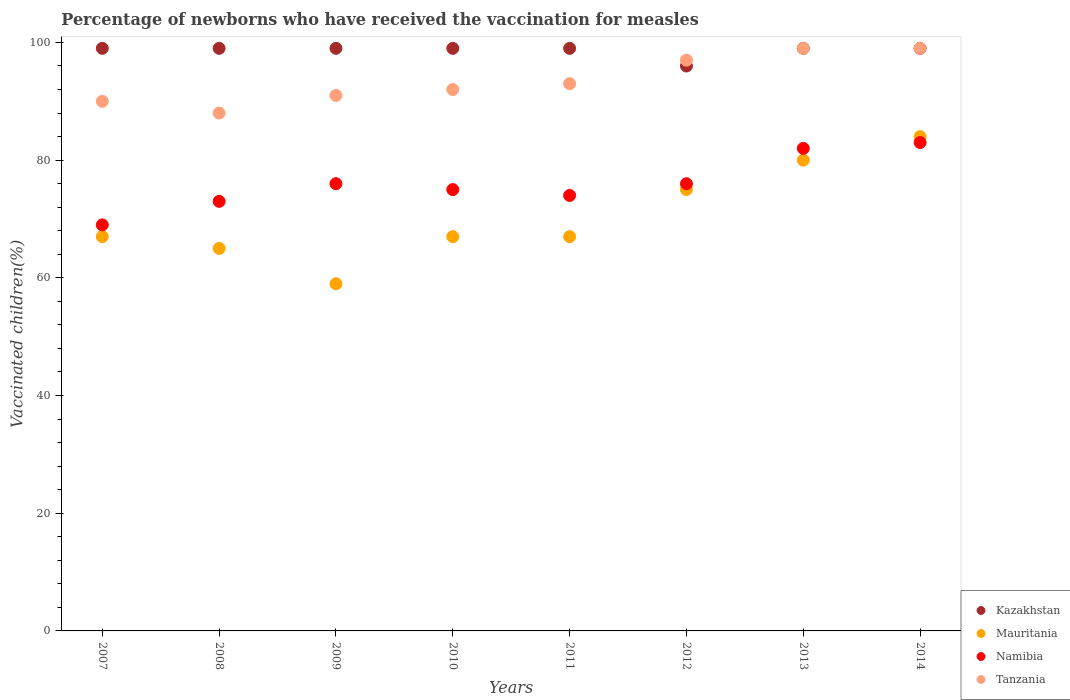Is the number of dotlines equal to the number of legend labels?
Offer a terse response. Yes. What is the percentage of vaccinated children in Tanzania in 2013?
Your response must be concise. 99. In which year was the percentage of vaccinated children in Namibia maximum?
Ensure brevity in your answer.  2014. What is the total percentage of vaccinated children in Tanzania in the graph?
Offer a very short reply. 749. What is the difference between the percentage of vaccinated children in Tanzania in 2010 and that in 2013?
Keep it short and to the point. -7. What is the difference between the percentage of vaccinated children in Mauritania in 2014 and the percentage of vaccinated children in Kazakhstan in 2009?
Your response must be concise. -15. What is the average percentage of vaccinated children in Namibia per year?
Your response must be concise. 76. In the year 2014, what is the difference between the percentage of vaccinated children in Mauritania and percentage of vaccinated children in Namibia?
Provide a short and direct response. 1. What is the ratio of the percentage of vaccinated children in Mauritania in 2012 to that in 2014?
Your response must be concise. 0.89. Is the percentage of vaccinated children in Kazakhstan in 2009 less than that in 2012?
Your answer should be compact. No. What is the difference between the highest and the second highest percentage of vaccinated children in Mauritania?
Keep it short and to the point. 4. What is the difference between the highest and the lowest percentage of vaccinated children in Namibia?
Your answer should be compact. 14. In how many years, is the percentage of vaccinated children in Tanzania greater than the average percentage of vaccinated children in Tanzania taken over all years?
Keep it short and to the point. 3. Is the sum of the percentage of vaccinated children in Kazakhstan in 2007 and 2014 greater than the maximum percentage of vaccinated children in Tanzania across all years?
Provide a succinct answer. Yes. Is it the case that in every year, the sum of the percentage of vaccinated children in Kazakhstan and percentage of vaccinated children in Namibia  is greater than the percentage of vaccinated children in Mauritania?
Offer a very short reply. Yes. What is the difference between two consecutive major ticks on the Y-axis?
Ensure brevity in your answer.  20. Does the graph contain any zero values?
Make the answer very short. No. Does the graph contain grids?
Offer a terse response. No. How are the legend labels stacked?
Give a very brief answer. Vertical. What is the title of the graph?
Your answer should be very brief. Percentage of newborns who have received the vaccination for measles. What is the label or title of the X-axis?
Your response must be concise. Years. What is the label or title of the Y-axis?
Provide a succinct answer. Vaccinated children(%). What is the Vaccinated children(%) in Mauritania in 2008?
Your answer should be very brief. 65. What is the Vaccinated children(%) in Namibia in 2008?
Provide a succinct answer. 73. What is the Vaccinated children(%) in Kazakhstan in 2009?
Provide a succinct answer. 99. What is the Vaccinated children(%) of Namibia in 2009?
Keep it short and to the point. 76. What is the Vaccinated children(%) of Tanzania in 2009?
Make the answer very short. 91. What is the Vaccinated children(%) of Kazakhstan in 2010?
Give a very brief answer. 99. What is the Vaccinated children(%) in Mauritania in 2010?
Your response must be concise. 67. What is the Vaccinated children(%) in Tanzania in 2010?
Make the answer very short. 92. What is the Vaccinated children(%) in Mauritania in 2011?
Your answer should be compact. 67. What is the Vaccinated children(%) in Namibia in 2011?
Provide a succinct answer. 74. What is the Vaccinated children(%) in Tanzania in 2011?
Ensure brevity in your answer.  93. What is the Vaccinated children(%) in Kazakhstan in 2012?
Offer a very short reply. 96. What is the Vaccinated children(%) of Tanzania in 2012?
Offer a very short reply. 97. What is the Vaccinated children(%) of Kazakhstan in 2013?
Offer a very short reply. 99. What is the Vaccinated children(%) of Mauritania in 2014?
Give a very brief answer. 84. What is the Vaccinated children(%) in Namibia in 2014?
Your response must be concise. 83. Across all years, what is the maximum Vaccinated children(%) of Kazakhstan?
Your answer should be compact. 99. Across all years, what is the maximum Vaccinated children(%) of Mauritania?
Your answer should be very brief. 84. Across all years, what is the maximum Vaccinated children(%) in Tanzania?
Provide a short and direct response. 99. Across all years, what is the minimum Vaccinated children(%) in Kazakhstan?
Your response must be concise. 96. Across all years, what is the minimum Vaccinated children(%) in Mauritania?
Your response must be concise. 59. What is the total Vaccinated children(%) of Kazakhstan in the graph?
Give a very brief answer. 789. What is the total Vaccinated children(%) in Mauritania in the graph?
Offer a very short reply. 564. What is the total Vaccinated children(%) in Namibia in the graph?
Make the answer very short. 608. What is the total Vaccinated children(%) in Tanzania in the graph?
Offer a terse response. 749. What is the difference between the Vaccinated children(%) in Tanzania in 2007 and that in 2008?
Your answer should be compact. 2. What is the difference between the Vaccinated children(%) in Kazakhstan in 2007 and that in 2009?
Your answer should be very brief. 0. What is the difference between the Vaccinated children(%) of Mauritania in 2007 and that in 2009?
Give a very brief answer. 8. What is the difference between the Vaccinated children(%) of Namibia in 2007 and that in 2009?
Your answer should be very brief. -7. What is the difference between the Vaccinated children(%) in Kazakhstan in 2007 and that in 2010?
Your answer should be compact. 0. What is the difference between the Vaccinated children(%) of Tanzania in 2007 and that in 2010?
Make the answer very short. -2. What is the difference between the Vaccinated children(%) in Kazakhstan in 2007 and that in 2011?
Provide a short and direct response. 0. What is the difference between the Vaccinated children(%) in Mauritania in 2007 and that in 2011?
Your response must be concise. 0. What is the difference between the Vaccinated children(%) in Tanzania in 2007 and that in 2011?
Your answer should be compact. -3. What is the difference between the Vaccinated children(%) in Kazakhstan in 2007 and that in 2012?
Provide a succinct answer. 3. What is the difference between the Vaccinated children(%) of Tanzania in 2007 and that in 2012?
Make the answer very short. -7. What is the difference between the Vaccinated children(%) in Namibia in 2007 and that in 2013?
Give a very brief answer. -13. What is the difference between the Vaccinated children(%) in Tanzania in 2007 and that in 2013?
Offer a terse response. -9. What is the difference between the Vaccinated children(%) of Mauritania in 2007 and that in 2014?
Provide a short and direct response. -17. What is the difference between the Vaccinated children(%) in Namibia in 2007 and that in 2014?
Offer a terse response. -14. What is the difference between the Vaccinated children(%) in Mauritania in 2008 and that in 2009?
Keep it short and to the point. 6. What is the difference between the Vaccinated children(%) of Namibia in 2008 and that in 2009?
Ensure brevity in your answer.  -3. What is the difference between the Vaccinated children(%) of Mauritania in 2008 and that in 2010?
Keep it short and to the point. -2. What is the difference between the Vaccinated children(%) of Kazakhstan in 2008 and that in 2011?
Keep it short and to the point. 0. What is the difference between the Vaccinated children(%) of Mauritania in 2008 and that in 2011?
Your answer should be very brief. -2. What is the difference between the Vaccinated children(%) of Namibia in 2008 and that in 2011?
Give a very brief answer. -1. What is the difference between the Vaccinated children(%) in Kazakhstan in 2008 and that in 2012?
Give a very brief answer. 3. What is the difference between the Vaccinated children(%) of Tanzania in 2008 and that in 2012?
Ensure brevity in your answer.  -9. What is the difference between the Vaccinated children(%) in Kazakhstan in 2008 and that in 2013?
Make the answer very short. 0. What is the difference between the Vaccinated children(%) in Namibia in 2008 and that in 2013?
Keep it short and to the point. -9. What is the difference between the Vaccinated children(%) of Namibia in 2008 and that in 2014?
Ensure brevity in your answer.  -10. What is the difference between the Vaccinated children(%) in Kazakhstan in 2009 and that in 2010?
Give a very brief answer. 0. What is the difference between the Vaccinated children(%) in Mauritania in 2009 and that in 2010?
Your answer should be very brief. -8. What is the difference between the Vaccinated children(%) of Tanzania in 2009 and that in 2010?
Give a very brief answer. -1. What is the difference between the Vaccinated children(%) in Mauritania in 2009 and that in 2011?
Keep it short and to the point. -8. What is the difference between the Vaccinated children(%) in Kazakhstan in 2009 and that in 2012?
Provide a succinct answer. 3. What is the difference between the Vaccinated children(%) in Mauritania in 2009 and that in 2013?
Offer a terse response. -21. What is the difference between the Vaccinated children(%) in Mauritania in 2009 and that in 2014?
Your response must be concise. -25. What is the difference between the Vaccinated children(%) in Namibia in 2009 and that in 2014?
Offer a terse response. -7. What is the difference between the Vaccinated children(%) in Mauritania in 2010 and that in 2011?
Your response must be concise. 0. What is the difference between the Vaccinated children(%) of Namibia in 2010 and that in 2011?
Offer a very short reply. 1. What is the difference between the Vaccinated children(%) in Tanzania in 2010 and that in 2011?
Make the answer very short. -1. What is the difference between the Vaccinated children(%) in Namibia in 2010 and that in 2012?
Provide a short and direct response. -1. What is the difference between the Vaccinated children(%) in Namibia in 2010 and that in 2013?
Ensure brevity in your answer.  -7. What is the difference between the Vaccinated children(%) of Kazakhstan in 2010 and that in 2014?
Your answer should be compact. 0. What is the difference between the Vaccinated children(%) in Namibia in 2010 and that in 2014?
Ensure brevity in your answer.  -8. What is the difference between the Vaccinated children(%) in Tanzania in 2010 and that in 2014?
Ensure brevity in your answer.  -7. What is the difference between the Vaccinated children(%) of Kazakhstan in 2011 and that in 2012?
Your answer should be very brief. 3. What is the difference between the Vaccinated children(%) of Namibia in 2011 and that in 2012?
Ensure brevity in your answer.  -2. What is the difference between the Vaccinated children(%) of Tanzania in 2011 and that in 2012?
Your answer should be compact. -4. What is the difference between the Vaccinated children(%) in Kazakhstan in 2011 and that in 2013?
Your answer should be very brief. 0. What is the difference between the Vaccinated children(%) of Namibia in 2011 and that in 2014?
Offer a very short reply. -9. What is the difference between the Vaccinated children(%) in Tanzania in 2011 and that in 2014?
Your answer should be compact. -6. What is the difference between the Vaccinated children(%) in Namibia in 2012 and that in 2013?
Offer a very short reply. -6. What is the difference between the Vaccinated children(%) in Tanzania in 2012 and that in 2013?
Provide a succinct answer. -2. What is the difference between the Vaccinated children(%) of Tanzania in 2012 and that in 2014?
Offer a terse response. -2. What is the difference between the Vaccinated children(%) of Kazakhstan in 2013 and that in 2014?
Your response must be concise. 0. What is the difference between the Vaccinated children(%) of Mauritania in 2013 and that in 2014?
Keep it short and to the point. -4. What is the difference between the Vaccinated children(%) in Namibia in 2013 and that in 2014?
Provide a short and direct response. -1. What is the difference between the Vaccinated children(%) of Tanzania in 2013 and that in 2014?
Your answer should be very brief. 0. What is the difference between the Vaccinated children(%) in Kazakhstan in 2007 and the Vaccinated children(%) in Mauritania in 2008?
Your answer should be compact. 34. What is the difference between the Vaccinated children(%) of Kazakhstan in 2007 and the Vaccinated children(%) of Tanzania in 2008?
Provide a short and direct response. 11. What is the difference between the Vaccinated children(%) of Kazakhstan in 2007 and the Vaccinated children(%) of Mauritania in 2009?
Keep it short and to the point. 40. What is the difference between the Vaccinated children(%) in Namibia in 2007 and the Vaccinated children(%) in Tanzania in 2009?
Provide a succinct answer. -22. What is the difference between the Vaccinated children(%) of Kazakhstan in 2007 and the Vaccinated children(%) of Mauritania in 2010?
Give a very brief answer. 32. What is the difference between the Vaccinated children(%) of Kazakhstan in 2007 and the Vaccinated children(%) of Tanzania in 2010?
Ensure brevity in your answer.  7. What is the difference between the Vaccinated children(%) of Mauritania in 2007 and the Vaccinated children(%) of Tanzania in 2010?
Keep it short and to the point. -25. What is the difference between the Vaccinated children(%) in Kazakhstan in 2007 and the Vaccinated children(%) in Mauritania in 2011?
Your answer should be very brief. 32. What is the difference between the Vaccinated children(%) of Kazakhstan in 2007 and the Vaccinated children(%) of Namibia in 2011?
Your answer should be very brief. 25. What is the difference between the Vaccinated children(%) of Kazakhstan in 2007 and the Vaccinated children(%) of Tanzania in 2011?
Your answer should be very brief. 6. What is the difference between the Vaccinated children(%) in Mauritania in 2007 and the Vaccinated children(%) in Namibia in 2011?
Offer a terse response. -7. What is the difference between the Vaccinated children(%) in Namibia in 2007 and the Vaccinated children(%) in Tanzania in 2011?
Provide a short and direct response. -24. What is the difference between the Vaccinated children(%) of Namibia in 2007 and the Vaccinated children(%) of Tanzania in 2012?
Make the answer very short. -28. What is the difference between the Vaccinated children(%) of Mauritania in 2007 and the Vaccinated children(%) of Namibia in 2013?
Your response must be concise. -15. What is the difference between the Vaccinated children(%) in Mauritania in 2007 and the Vaccinated children(%) in Tanzania in 2013?
Make the answer very short. -32. What is the difference between the Vaccinated children(%) of Kazakhstan in 2007 and the Vaccinated children(%) of Mauritania in 2014?
Provide a succinct answer. 15. What is the difference between the Vaccinated children(%) of Mauritania in 2007 and the Vaccinated children(%) of Namibia in 2014?
Provide a short and direct response. -16. What is the difference between the Vaccinated children(%) of Mauritania in 2007 and the Vaccinated children(%) of Tanzania in 2014?
Ensure brevity in your answer.  -32. What is the difference between the Vaccinated children(%) in Kazakhstan in 2008 and the Vaccinated children(%) in Namibia in 2009?
Provide a short and direct response. 23. What is the difference between the Vaccinated children(%) in Kazakhstan in 2008 and the Vaccinated children(%) in Tanzania in 2009?
Give a very brief answer. 8. What is the difference between the Vaccinated children(%) of Mauritania in 2008 and the Vaccinated children(%) of Namibia in 2009?
Offer a very short reply. -11. What is the difference between the Vaccinated children(%) of Mauritania in 2008 and the Vaccinated children(%) of Tanzania in 2009?
Offer a very short reply. -26. What is the difference between the Vaccinated children(%) in Kazakhstan in 2008 and the Vaccinated children(%) in Namibia in 2010?
Offer a terse response. 24. What is the difference between the Vaccinated children(%) of Kazakhstan in 2008 and the Vaccinated children(%) of Tanzania in 2010?
Keep it short and to the point. 7. What is the difference between the Vaccinated children(%) in Kazakhstan in 2008 and the Vaccinated children(%) in Mauritania in 2011?
Give a very brief answer. 32. What is the difference between the Vaccinated children(%) in Kazakhstan in 2008 and the Vaccinated children(%) in Namibia in 2011?
Offer a very short reply. 25. What is the difference between the Vaccinated children(%) of Kazakhstan in 2008 and the Vaccinated children(%) of Tanzania in 2011?
Your response must be concise. 6. What is the difference between the Vaccinated children(%) in Mauritania in 2008 and the Vaccinated children(%) in Namibia in 2011?
Make the answer very short. -9. What is the difference between the Vaccinated children(%) of Mauritania in 2008 and the Vaccinated children(%) of Namibia in 2012?
Provide a succinct answer. -11. What is the difference between the Vaccinated children(%) of Mauritania in 2008 and the Vaccinated children(%) of Tanzania in 2012?
Your response must be concise. -32. What is the difference between the Vaccinated children(%) of Namibia in 2008 and the Vaccinated children(%) of Tanzania in 2012?
Your answer should be very brief. -24. What is the difference between the Vaccinated children(%) of Kazakhstan in 2008 and the Vaccinated children(%) of Mauritania in 2013?
Ensure brevity in your answer.  19. What is the difference between the Vaccinated children(%) of Mauritania in 2008 and the Vaccinated children(%) of Tanzania in 2013?
Provide a short and direct response. -34. What is the difference between the Vaccinated children(%) of Namibia in 2008 and the Vaccinated children(%) of Tanzania in 2013?
Offer a very short reply. -26. What is the difference between the Vaccinated children(%) of Mauritania in 2008 and the Vaccinated children(%) of Tanzania in 2014?
Ensure brevity in your answer.  -34. What is the difference between the Vaccinated children(%) of Kazakhstan in 2009 and the Vaccinated children(%) of Mauritania in 2010?
Offer a very short reply. 32. What is the difference between the Vaccinated children(%) in Kazakhstan in 2009 and the Vaccinated children(%) in Namibia in 2010?
Keep it short and to the point. 24. What is the difference between the Vaccinated children(%) in Mauritania in 2009 and the Vaccinated children(%) in Tanzania in 2010?
Make the answer very short. -33. What is the difference between the Vaccinated children(%) of Namibia in 2009 and the Vaccinated children(%) of Tanzania in 2010?
Keep it short and to the point. -16. What is the difference between the Vaccinated children(%) of Kazakhstan in 2009 and the Vaccinated children(%) of Mauritania in 2011?
Provide a short and direct response. 32. What is the difference between the Vaccinated children(%) of Kazakhstan in 2009 and the Vaccinated children(%) of Namibia in 2011?
Give a very brief answer. 25. What is the difference between the Vaccinated children(%) in Mauritania in 2009 and the Vaccinated children(%) in Namibia in 2011?
Your answer should be very brief. -15. What is the difference between the Vaccinated children(%) of Mauritania in 2009 and the Vaccinated children(%) of Tanzania in 2011?
Your response must be concise. -34. What is the difference between the Vaccinated children(%) in Kazakhstan in 2009 and the Vaccinated children(%) in Mauritania in 2012?
Make the answer very short. 24. What is the difference between the Vaccinated children(%) of Kazakhstan in 2009 and the Vaccinated children(%) of Namibia in 2012?
Your answer should be very brief. 23. What is the difference between the Vaccinated children(%) in Kazakhstan in 2009 and the Vaccinated children(%) in Tanzania in 2012?
Your response must be concise. 2. What is the difference between the Vaccinated children(%) of Mauritania in 2009 and the Vaccinated children(%) of Tanzania in 2012?
Ensure brevity in your answer.  -38. What is the difference between the Vaccinated children(%) of Namibia in 2009 and the Vaccinated children(%) of Tanzania in 2012?
Give a very brief answer. -21. What is the difference between the Vaccinated children(%) of Kazakhstan in 2009 and the Vaccinated children(%) of Tanzania in 2013?
Give a very brief answer. 0. What is the difference between the Vaccinated children(%) of Mauritania in 2009 and the Vaccinated children(%) of Namibia in 2013?
Make the answer very short. -23. What is the difference between the Vaccinated children(%) in Mauritania in 2009 and the Vaccinated children(%) in Tanzania in 2013?
Provide a succinct answer. -40. What is the difference between the Vaccinated children(%) of Namibia in 2009 and the Vaccinated children(%) of Tanzania in 2013?
Offer a terse response. -23. What is the difference between the Vaccinated children(%) of Kazakhstan in 2009 and the Vaccinated children(%) of Namibia in 2014?
Your response must be concise. 16. What is the difference between the Vaccinated children(%) of Namibia in 2009 and the Vaccinated children(%) of Tanzania in 2014?
Offer a very short reply. -23. What is the difference between the Vaccinated children(%) of Kazakhstan in 2010 and the Vaccinated children(%) of Tanzania in 2011?
Your answer should be very brief. 6. What is the difference between the Vaccinated children(%) in Mauritania in 2010 and the Vaccinated children(%) in Tanzania in 2011?
Ensure brevity in your answer.  -26. What is the difference between the Vaccinated children(%) of Kazakhstan in 2010 and the Vaccinated children(%) of Namibia in 2012?
Give a very brief answer. 23. What is the difference between the Vaccinated children(%) of Mauritania in 2010 and the Vaccinated children(%) of Tanzania in 2012?
Your response must be concise. -30. What is the difference between the Vaccinated children(%) in Namibia in 2010 and the Vaccinated children(%) in Tanzania in 2012?
Ensure brevity in your answer.  -22. What is the difference between the Vaccinated children(%) of Kazakhstan in 2010 and the Vaccinated children(%) of Tanzania in 2013?
Give a very brief answer. 0. What is the difference between the Vaccinated children(%) of Mauritania in 2010 and the Vaccinated children(%) of Namibia in 2013?
Provide a succinct answer. -15. What is the difference between the Vaccinated children(%) in Mauritania in 2010 and the Vaccinated children(%) in Tanzania in 2013?
Offer a terse response. -32. What is the difference between the Vaccinated children(%) in Namibia in 2010 and the Vaccinated children(%) in Tanzania in 2013?
Offer a terse response. -24. What is the difference between the Vaccinated children(%) of Kazakhstan in 2010 and the Vaccinated children(%) of Mauritania in 2014?
Ensure brevity in your answer.  15. What is the difference between the Vaccinated children(%) of Kazakhstan in 2010 and the Vaccinated children(%) of Namibia in 2014?
Ensure brevity in your answer.  16. What is the difference between the Vaccinated children(%) of Mauritania in 2010 and the Vaccinated children(%) of Namibia in 2014?
Provide a succinct answer. -16. What is the difference between the Vaccinated children(%) in Mauritania in 2010 and the Vaccinated children(%) in Tanzania in 2014?
Provide a succinct answer. -32. What is the difference between the Vaccinated children(%) in Kazakhstan in 2011 and the Vaccinated children(%) in Mauritania in 2012?
Your response must be concise. 24. What is the difference between the Vaccinated children(%) in Kazakhstan in 2011 and the Vaccinated children(%) in Namibia in 2012?
Your answer should be very brief. 23. What is the difference between the Vaccinated children(%) in Mauritania in 2011 and the Vaccinated children(%) in Namibia in 2012?
Offer a very short reply. -9. What is the difference between the Vaccinated children(%) in Kazakhstan in 2011 and the Vaccinated children(%) in Tanzania in 2013?
Provide a succinct answer. 0. What is the difference between the Vaccinated children(%) in Mauritania in 2011 and the Vaccinated children(%) in Tanzania in 2013?
Ensure brevity in your answer.  -32. What is the difference between the Vaccinated children(%) in Namibia in 2011 and the Vaccinated children(%) in Tanzania in 2013?
Your answer should be compact. -25. What is the difference between the Vaccinated children(%) in Kazakhstan in 2011 and the Vaccinated children(%) in Mauritania in 2014?
Provide a short and direct response. 15. What is the difference between the Vaccinated children(%) of Mauritania in 2011 and the Vaccinated children(%) of Namibia in 2014?
Your response must be concise. -16. What is the difference between the Vaccinated children(%) of Mauritania in 2011 and the Vaccinated children(%) of Tanzania in 2014?
Give a very brief answer. -32. What is the difference between the Vaccinated children(%) of Kazakhstan in 2012 and the Vaccinated children(%) of Namibia in 2013?
Your response must be concise. 14. What is the difference between the Vaccinated children(%) in Namibia in 2012 and the Vaccinated children(%) in Tanzania in 2013?
Offer a terse response. -23. What is the difference between the Vaccinated children(%) in Kazakhstan in 2012 and the Vaccinated children(%) in Tanzania in 2014?
Offer a very short reply. -3. What is the difference between the Vaccinated children(%) of Kazakhstan in 2013 and the Vaccinated children(%) of Mauritania in 2014?
Keep it short and to the point. 15. What is the difference between the Vaccinated children(%) in Namibia in 2013 and the Vaccinated children(%) in Tanzania in 2014?
Keep it short and to the point. -17. What is the average Vaccinated children(%) in Kazakhstan per year?
Keep it short and to the point. 98.62. What is the average Vaccinated children(%) in Mauritania per year?
Offer a terse response. 70.5. What is the average Vaccinated children(%) in Tanzania per year?
Make the answer very short. 93.62. In the year 2007, what is the difference between the Vaccinated children(%) in Kazakhstan and Vaccinated children(%) in Mauritania?
Ensure brevity in your answer.  32. In the year 2007, what is the difference between the Vaccinated children(%) of Mauritania and Vaccinated children(%) of Namibia?
Your answer should be very brief. -2. In the year 2007, what is the difference between the Vaccinated children(%) in Mauritania and Vaccinated children(%) in Tanzania?
Provide a succinct answer. -23. In the year 2007, what is the difference between the Vaccinated children(%) in Namibia and Vaccinated children(%) in Tanzania?
Offer a terse response. -21. In the year 2008, what is the difference between the Vaccinated children(%) in Namibia and Vaccinated children(%) in Tanzania?
Your response must be concise. -15. In the year 2009, what is the difference between the Vaccinated children(%) of Kazakhstan and Vaccinated children(%) of Mauritania?
Provide a succinct answer. 40. In the year 2009, what is the difference between the Vaccinated children(%) of Kazakhstan and Vaccinated children(%) of Namibia?
Make the answer very short. 23. In the year 2009, what is the difference between the Vaccinated children(%) in Mauritania and Vaccinated children(%) in Tanzania?
Ensure brevity in your answer.  -32. In the year 2009, what is the difference between the Vaccinated children(%) in Namibia and Vaccinated children(%) in Tanzania?
Offer a terse response. -15. In the year 2010, what is the difference between the Vaccinated children(%) of Kazakhstan and Vaccinated children(%) of Tanzania?
Ensure brevity in your answer.  7. In the year 2010, what is the difference between the Vaccinated children(%) in Mauritania and Vaccinated children(%) in Namibia?
Your answer should be compact. -8. In the year 2011, what is the difference between the Vaccinated children(%) in Kazakhstan and Vaccinated children(%) in Mauritania?
Offer a very short reply. 32. In the year 2011, what is the difference between the Vaccinated children(%) of Mauritania and Vaccinated children(%) of Namibia?
Give a very brief answer. -7. In the year 2011, what is the difference between the Vaccinated children(%) of Mauritania and Vaccinated children(%) of Tanzania?
Your answer should be very brief. -26. In the year 2012, what is the difference between the Vaccinated children(%) in Kazakhstan and Vaccinated children(%) in Tanzania?
Give a very brief answer. -1. In the year 2012, what is the difference between the Vaccinated children(%) of Mauritania and Vaccinated children(%) of Namibia?
Offer a terse response. -1. In the year 2012, what is the difference between the Vaccinated children(%) of Mauritania and Vaccinated children(%) of Tanzania?
Offer a terse response. -22. In the year 2012, what is the difference between the Vaccinated children(%) in Namibia and Vaccinated children(%) in Tanzania?
Offer a very short reply. -21. In the year 2013, what is the difference between the Vaccinated children(%) in Kazakhstan and Vaccinated children(%) in Mauritania?
Your answer should be compact. 19. In the year 2013, what is the difference between the Vaccinated children(%) in Kazakhstan and Vaccinated children(%) in Tanzania?
Your answer should be compact. 0. In the year 2013, what is the difference between the Vaccinated children(%) in Mauritania and Vaccinated children(%) in Tanzania?
Make the answer very short. -19. In the year 2013, what is the difference between the Vaccinated children(%) in Namibia and Vaccinated children(%) in Tanzania?
Make the answer very short. -17. In the year 2014, what is the difference between the Vaccinated children(%) in Kazakhstan and Vaccinated children(%) in Mauritania?
Offer a terse response. 15. In the year 2014, what is the difference between the Vaccinated children(%) of Mauritania and Vaccinated children(%) of Namibia?
Your answer should be very brief. 1. In the year 2014, what is the difference between the Vaccinated children(%) in Mauritania and Vaccinated children(%) in Tanzania?
Ensure brevity in your answer.  -15. In the year 2014, what is the difference between the Vaccinated children(%) of Namibia and Vaccinated children(%) of Tanzania?
Your response must be concise. -16. What is the ratio of the Vaccinated children(%) in Mauritania in 2007 to that in 2008?
Keep it short and to the point. 1.03. What is the ratio of the Vaccinated children(%) of Namibia in 2007 to that in 2008?
Offer a terse response. 0.95. What is the ratio of the Vaccinated children(%) of Tanzania in 2007 to that in 2008?
Your answer should be very brief. 1.02. What is the ratio of the Vaccinated children(%) of Kazakhstan in 2007 to that in 2009?
Provide a succinct answer. 1. What is the ratio of the Vaccinated children(%) in Mauritania in 2007 to that in 2009?
Give a very brief answer. 1.14. What is the ratio of the Vaccinated children(%) in Namibia in 2007 to that in 2009?
Keep it short and to the point. 0.91. What is the ratio of the Vaccinated children(%) of Tanzania in 2007 to that in 2009?
Provide a short and direct response. 0.99. What is the ratio of the Vaccinated children(%) in Mauritania in 2007 to that in 2010?
Provide a short and direct response. 1. What is the ratio of the Vaccinated children(%) of Namibia in 2007 to that in 2010?
Keep it short and to the point. 0.92. What is the ratio of the Vaccinated children(%) in Tanzania in 2007 to that in 2010?
Your response must be concise. 0.98. What is the ratio of the Vaccinated children(%) in Mauritania in 2007 to that in 2011?
Your answer should be compact. 1. What is the ratio of the Vaccinated children(%) of Namibia in 2007 to that in 2011?
Provide a short and direct response. 0.93. What is the ratio of the Vaccinated children(%) in Kazakhstan in 2007 to that in 2012?
Your answer should be very brief. 1.03. What is the ratio of the Vaccinated children(%) in Mauritania in 2007 to that in 2012?
Offer a very short reply. 0.89. What is the ratio of the Vaccinated children(%) in Namibia in 2007 to that in 2012?
Offer a very short reply. 0.91. What is the ratio of the Vaccinated children(%) in Tanzania in 2007 to that in 2012?
Ensure brevity in your answer.  0.93. What is the ratio of the Vaccinated children(%) in Kazakhstan in 2007 to that in 2013?
Your response must be concise. 1. What is the ratio of the Vaccinated children(%) of Mauritania in 2007 to that in 2013?
Offer a terse response. 0.84. What is the ratio of the Vaccinated children(%) in Namibia in 2007 to that in 2013?
Make the answer very short. 0.84. What is the ratio of the Vaccinated children(%) in Tanzania in 2007 to that in 2013?
Your answer should be very brief. 0.91. What is the ratio of the Vaccinated children(%) in Kazakhstan in 2007 to that in 2014?
Your answer should be very brief. 1. What is the ratio of the Vaccinated children(%) of Mauritania in 2007 to that in 2014?
Make the answer very short. 0.8. What is the ratio of the Vaccinated children(%) of Namibia in 2007 to that in 2014?
Give a very brief answer. 0.83. What is the ratio of the Vaccinated children(%) of Mauritania in 2008 to that in 2009?
Your response must be concise. 1.1. What is the ratio of the Vaccinated children(%) of Namibia in 2008 to that in 2009?
Your answer should be compact. 0.96. What is the ratio of the Vaccinated children(%) of Tanzania in 2008 to that in 2009?
Your response must be concise. 0.97. What is the ratio of the Vaccinated children(%) in Kazakhstan in 2008 to that in 2010?
Give a very brief answer. 1. What is the ratio of the Vaccinated children(%) in Mauritania in 2008 to that in 2010?
Provide a succinct answer. 0.97. What is the ratio of the Vaccinated children(%) in Namibia in 2008 to that in 2010?
Offer a terse response. 0.97. What is the ratio of the Vaccinated children(%) of Tanzania in 2008 to that in 2010?
Your answer should be very brief. 0.96. What is the ratio of the Vaccinated children(%) of Mauritania in 2008 to that in 2011?
Keep it short and to the point. 0.97. What is the ratio of the Vaccinated children(%) of Namibia in 2008 to that in 2011?
Your answer should be compact. 0.99. What is the ratio of the Vaccinated children(%) in Tanzania in 2008 to that in 2011?
Your answer should be compact. 0.95. What is the ratio of the Vaccinated children(%) of Kazakhstan in 2008 to that in 2012?
Offer a terse response. 1.03. What is the ratio of the Vaccinated children(%) in Mauritania in 2008 to that in 2012?
Your answer should be very brief. 0.87. What is the ratio of the Vaccinated children(%) of Namibia in 2008 to that in 2012?
Give a very brief answer. 0.96. What is the ratio of the Vaccinated children(%) of Tanzania in 2008 to that in 2012?
Your response must be concise. 0.91. What is the ratio of the Vaccinated children(%) in Mauritania in 2008 to that in 2013?
Provide a succinct answer. 0.81. What is the ratio of the Vaccinated children(%) of Namibia in 2008 to that in 2013?
Make the answer very short. 0.89. What is the ratio of the Vaccinated children(%) in Mauritania in 2008 to that in 2014?
Ensure brevity in your answer.  0.77. What is the ratio of the Vaccinated children(%) in Namibia in 2008 to that in 2014?
Your answer should be compact. 0.88. What is the ratio of the Vaccinated children(%) of Tanzania in 2008 to that in 2014?
Ensure brevity in your answer.  0.89. What is the ratio of the Vaccinated children(%) in Kazakhstan in 2009 to that in 2010?
Ensure brevity in your answer.  1. What is the ratio of the Vaccinated children(%) of Mauritania in 2009 to that in 2010?
Offer a very short reply. 0.88. What is the ratio of the Vaccinated children(%) of Namibia in 2009 to that in 2010?
Make the answer very short. 1.01. What is the ratio of the Vaccinated children(%) of Mauritania in 2009 to that in 2011?
Keep it short and to the point. 0.88. What is the ratio of the Vaccinated children(%) of Namibia in 2009 to that in 2011?
Your answer should be compact. 1.03. What is the ratio of the Vaccinated children(%) of Tanzania in 2009 to that in 2011?
Your answer should be very brief. 0.98. What is the ratio of the Vaccinated children(%) of Kazakhstan in 2009 to that in 2012?
Provide a short and direct response. 1.03. What is the ratio of the Vaccinated children(%) in Mauritania in 2009 to that in 2012?
Keep it short and to the point. 0.79. What is the ratio of the Vaccinated children(%) in Namibia in 2009 to that in 2012?
Provide a short and direct response. 1. What is the ratio of the Vaccinated children(%) in Tanzania in 2009 to that in 2012?
Give a very brief answer. 0.94. What is the ratio of the Vaccinated children(%) in Mauritania in 2009 to that in 2013?
Your answer should be compact. 0.74. What is the ratio of the Vaccinated children(%) of Namibia in 2009 to that in 2013?
Make the answer very short. 0.93. What is the ratio of the Vaccinated children(%) in Tanzania in 2009 to that in 2013?
Ensure brevity in your answer.  0.92. What is the ratio of the Vaccinated children(%) in Kazakhstan in 2009 to that in 2014?
Your response must be concise. 1. What is the ratio of the Vaccinated children(%) of Mauritania in 2009 to that in 2014?
Your response must be concise. 0.7. What is the ratio of the Vaccinated children(%) of Namibia in 2009 to that in 2014?
Provide a succinct answer. 0.92. What is the ratio of the Vaccinated children(%) in Tanzania in 2009 to that in 2014?
Keep it short and to the point. 0.92. What is the ratio of the Vaccinated children(%) of Kazakhstan in 2010 to that in 2011?
Give a very brief answer. 1. What is the ratio of the Vaccinated children(%) in Mauritania in 2010 to that in 2011?
Your answer should be very brief. 1. What is the ratio of the Vaccinated children(%) in Namibia in 2010 to that in 2011?
Your answer should be very brief. 1.01. What is the ratio of the Vaccinated children(%) in Tanzania in 2010 to that in 2011?
Your answer should be compact. 0.99. What is the ratio of the Vaccinated children(%) in Kazakhstan in 2010 to that in 2012?
Make the answer very short. 1.03. What is the ratio of the Vaccinated children(%) in Mauritania in 2010 to that in 2012?
Provide a succinct answer. 0.89. What is the ratio of the Vaccinated children(%) of Tanzania in 2010 to that in 2012?
Offer a very short reply. 0.95. What is the ratio of the Vaccinated children(%) of Kazakhstan in 2010 to that in 2013?
Give a very brief answer. 1. What is the ratio of the Vaccinated children(%) of Mauritania in 2010 to that in 2013?
Your answer should be compact. 0.84. What is the ratio of the Vaccinated children(%) of Namibia in 2010 to that in 2013?
Offer a terse response. 0.91. What is the ratio of the Vaccinated children(%) of Tanzania in 2010 to that in 2013?
Your answer should be compact. 0.93. What is the ratio of the Vaccinated children(%) of Mauritania in 2010 to that in 2014?
Your answer should be compact. 0.8. What is the ratio of the Vaccinated children(%) of Namibia in 2010 to that in 2014?
Provide a short and direct response. 0.9. What is the ratio of the Vaccinated children(%) in Tanzania in 2010 to that in 2014?
Provide a succinct answer. 0.93. What is the ratio of the Vaccinated children(%) of Kazakhstan in 2011 to that in 2012?
Give a very brief answer. 1.03. What is the ratio of the Vaccinated children(%) in Mauritania in 2011 to that in 2012?
Offer a terse response. 0.89. What is the ratio of the Vaccinated children(%) of Namibia in 2011 to that in 2012?
Provide a succinct answer. 0.97. What is the ratio of the Vaccinated children(%) in Tanzania in 2011 to that in 2012?
Provide a short and direct response. 0.96. What is the ratio of the Vaccinated children(%) in Mauritania in 2011 to that in 2013?
Offer a terse response. 0.84. What is the ratio of the Vaccinated children(%) of Namibia in 2011 to that in 2013?
Offer a terse response. 0.9. What is the ratio of the Vaccinated children(%) of Tanzania in 2011 to that in 2013?
Your answer should be compact. 0.94. What is the ratio of the Vaccinated children(%) in Mauritania in 2011 to that in 2014?
Ensure brevity in your answer.  0.8. What is the ratio of the Vaccinated children(%) in Namibia in 2011 to that in 2014?
Offer a terse response. 0.89. What is the ratio of the Vaccinated children(%) of Tanzania in 2011 to that in 2014?
Give a very brief answer. 0.94. What is the ratio of the Vaccinated children(%) in Kazakhstan in 2012 to that in 2013?
Offer a terse response. 0.97. What is the ratio of the Vaccinated children(%) of Namibia in 2012 to that in 2013?
Make the answer very short. 0.93. What is the ratio of the Vaccinated children(%) in Tanzania in 2012 to that in 2013?
Your answer should be very brief. 0.98. What is the ratio of the Vaccinated children(%) in Kazakhstan in 2012 to that in 2014?
Make the answer very short. 0.97. What is the ratio of the Vaccinated children(%) of Mauritania in 2012 to that in 2014?
Provide a short and direct response. 0.89. What is the ratio of the Vaccinated children(%) of Namibia in 2012 to that in 2014?
Make the answer very short. 0.92. What is the ratio of the Vaccinated children(%) of Tanzania in 2012 to that in 2014?
Your answer should be compact. 0.98. What is the ratio of the Vaccinated children(%) of Tanzania in 2013 to that in 2014?
Your answer should be compact. 1. What is the difference between the highest and the lowest Vaccinated children(%) of Tanzania?
Offer a terse response. 11. 